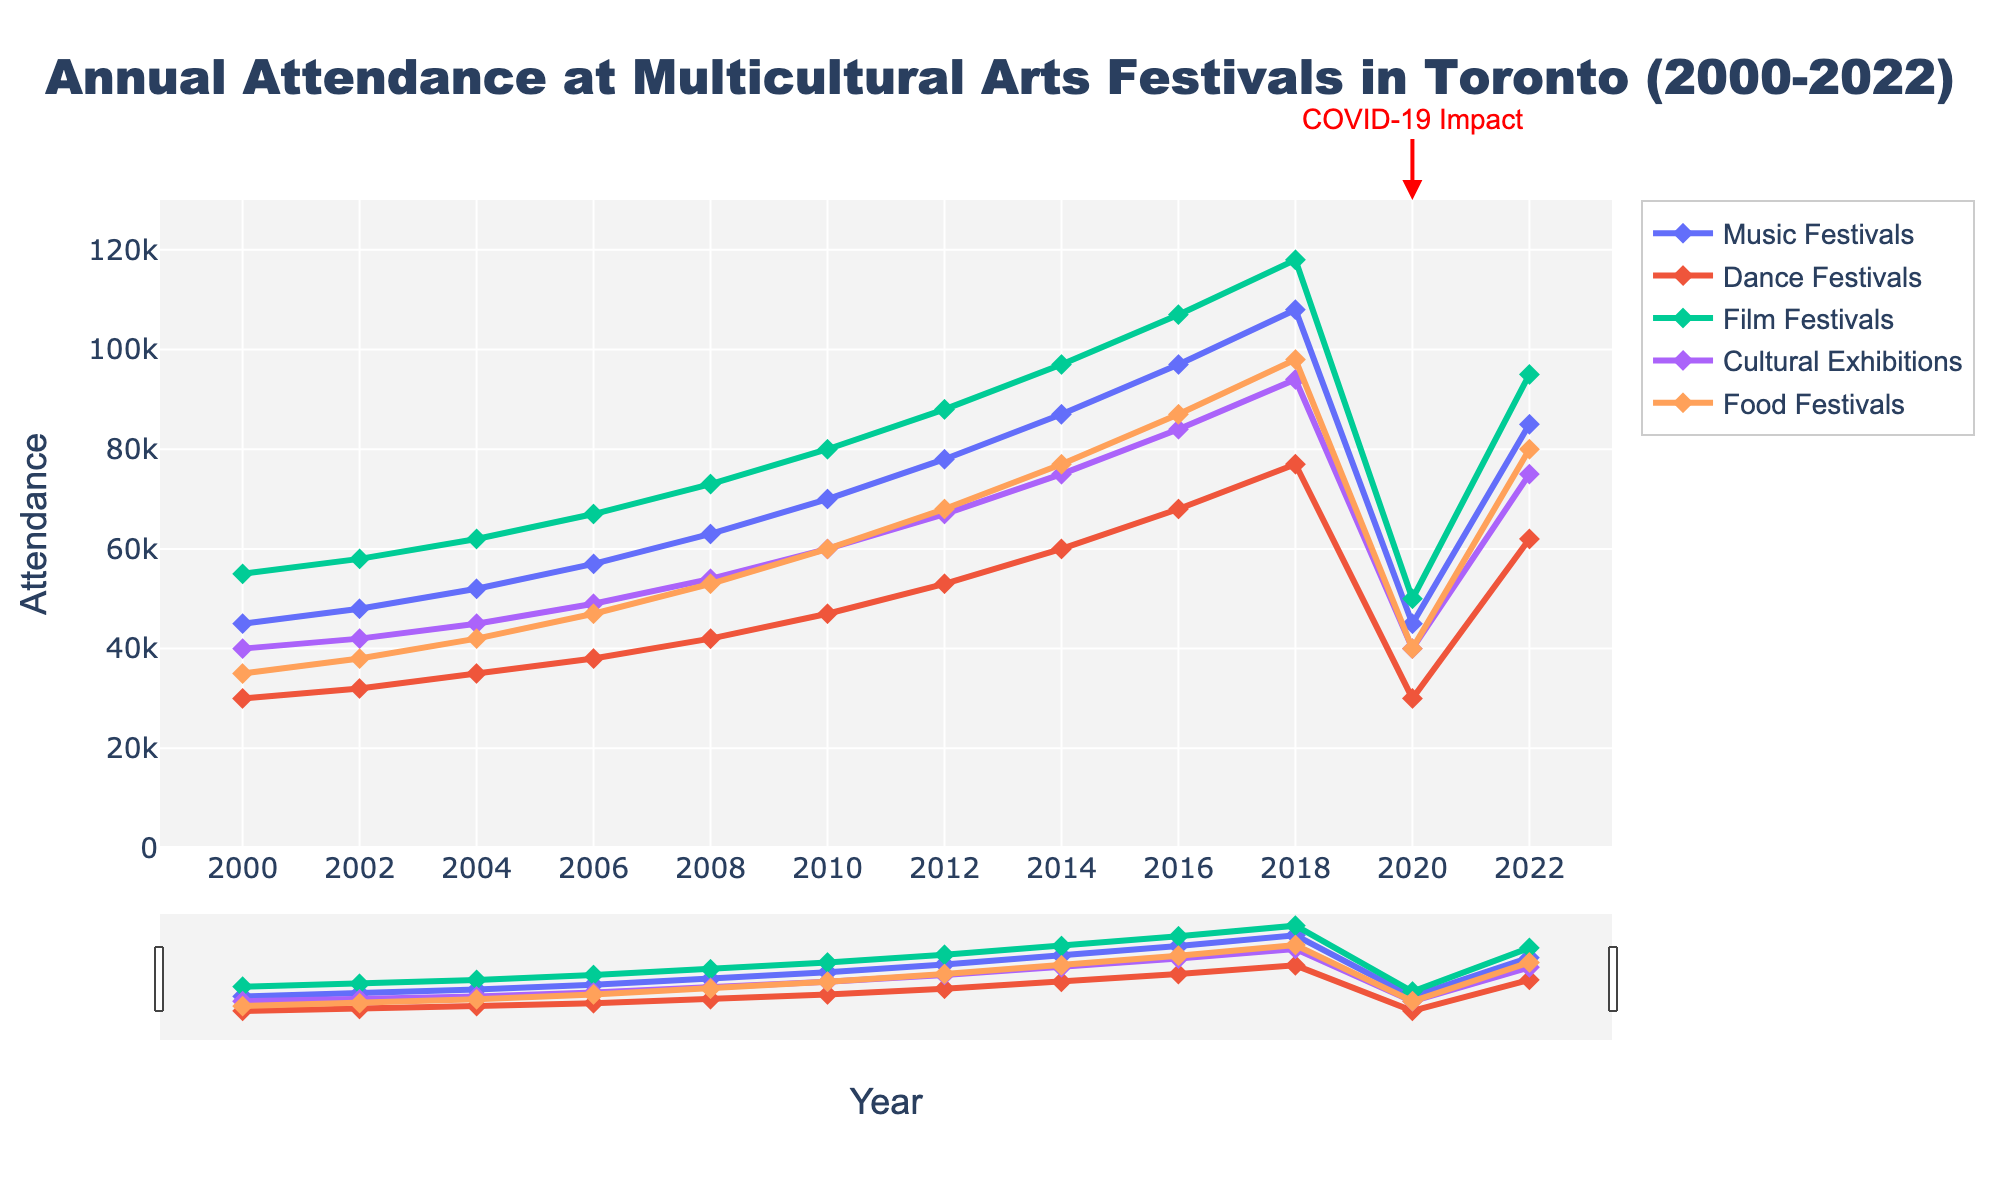How did attendance at Music Festivals change from 2000 to 2022? First, look at the attendance for Music Festivals in 2000, which is 45,000. Then, look at the attendance in 2022, which is 85,000. The difference is 85,000 - 45,000 = 40,000, indicating an increase of 40,000.
Answer: It increased by 40,000 Which event type had the highest attendance in 2022? Look at the attendance figures for all event types in 2022. Film Festivals had the highest attendance with 95,000, followed by Food Festivals with 80,000, Cultural Exhibitions with 75,000, Music Festivals with 85,000, and Dance Festivals with 62,000.
Answer: Film Festivals What is the average attendance for Food Festivals over the years 2000 to 2022? Sum the attendance figures for the years 2000 to 2022 and then divide by the number of years. (35000 + 38000 + 42000 + 47000 + 53000 + 60000 + 68000 + 77000 + 87000 + 98000 + 40000 + 80000) / 12 = 64083.3
Answer: 64083.3 Did any event types experience a decline in attendance in 2020 compared to 2018? Compare the attendance figures for each event type in 2018 and 2020. Music Festivals: 108,000 to 45,000, Dance Festivals: 77,000 to 30,000, Film Festivals: 118,000 to 50,000, Cultural Exhibitions: 94,000 to 40,000, and Food Festivals: 98,000 to 40,000. All event types experienced a decline.
Answer: Yes, all types Which event type had the smallest attendance drop in 2020 compared to 2018? Calculate the difference for each event type between 2018 and 2020. Music Festivals: 108,000 - 45,000 = 63,000; Dance Festivals: 77,000 - 30,000 = 47,000; Film Festivals: 118,000 - 50,000 = 68,000; Cultural Exhibitions: 94,000 - 40,000 = 54,000; Food Festivals: 98,000 - 40,000 = 58,000. Dance Festivals had the smallest drop of 47,000.
Answer: Dance Festivals What trend did Food Festivals experience from 2000 to 2018 before the decline in 2020? Look at the attendance figures from 2000 to 2018. The attendance increased steadily from 35,000 in 2000 to 98,000 in 2018, showing an upward trend.
Answer: Upward trend What was the combined attendance for Music and Dance Festivals in 2016? Sum the attendance figures for Music Festivals and Dance Festivals in 2016: 97,000 (Music Festivals) + 68,000 (Dance Festivals) = 165,000.
Answer: 165,000 How did Cultural Exhibitions attendance change during the 2008 financial crisis? Compare the attendance in 2006 (49,000) and 2010 (60,000). There was an increase despite the financial crisis, from 49,000 to 60,000.
Answer: Increased Which event type had the most consistent growth from 2000 to 2018? Look at the growth patterns for all event types. Both Film Festivals and Food Festivals show consistent growth without large jumps or declines. Comparing the figures, Film Festivals consistently increased from 55,000 in 2000 to 118,000 in 2018.
Answer: Film Festivals 